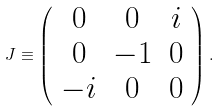Convert formula to latex. <formula><loc_0><loc_0><loc_500><loc_500>J \equiv \left ( \begin{array} { c c c } 0 & 0 & i \\ 0 & - 1 & 0 \\ - i & 0 & 0 \end{array} \right ) .</formula> 